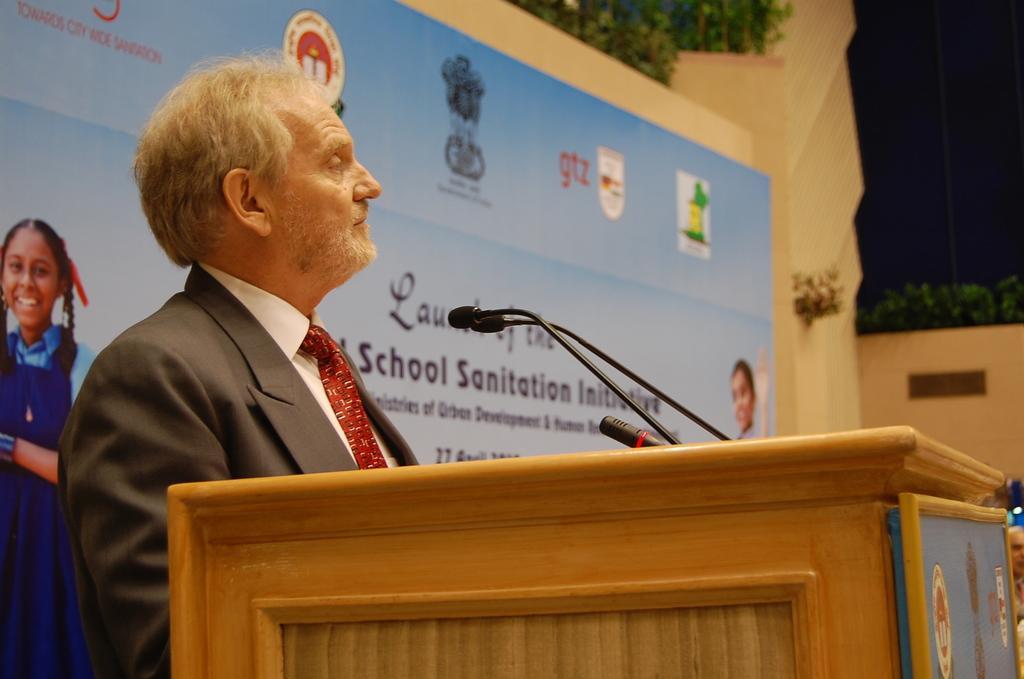In one or two sentences, can you explain what this image depicts? In this image we can see a man standing at the podium and mics are attached to it. In the background there is an advertisement to the wall and plants. 